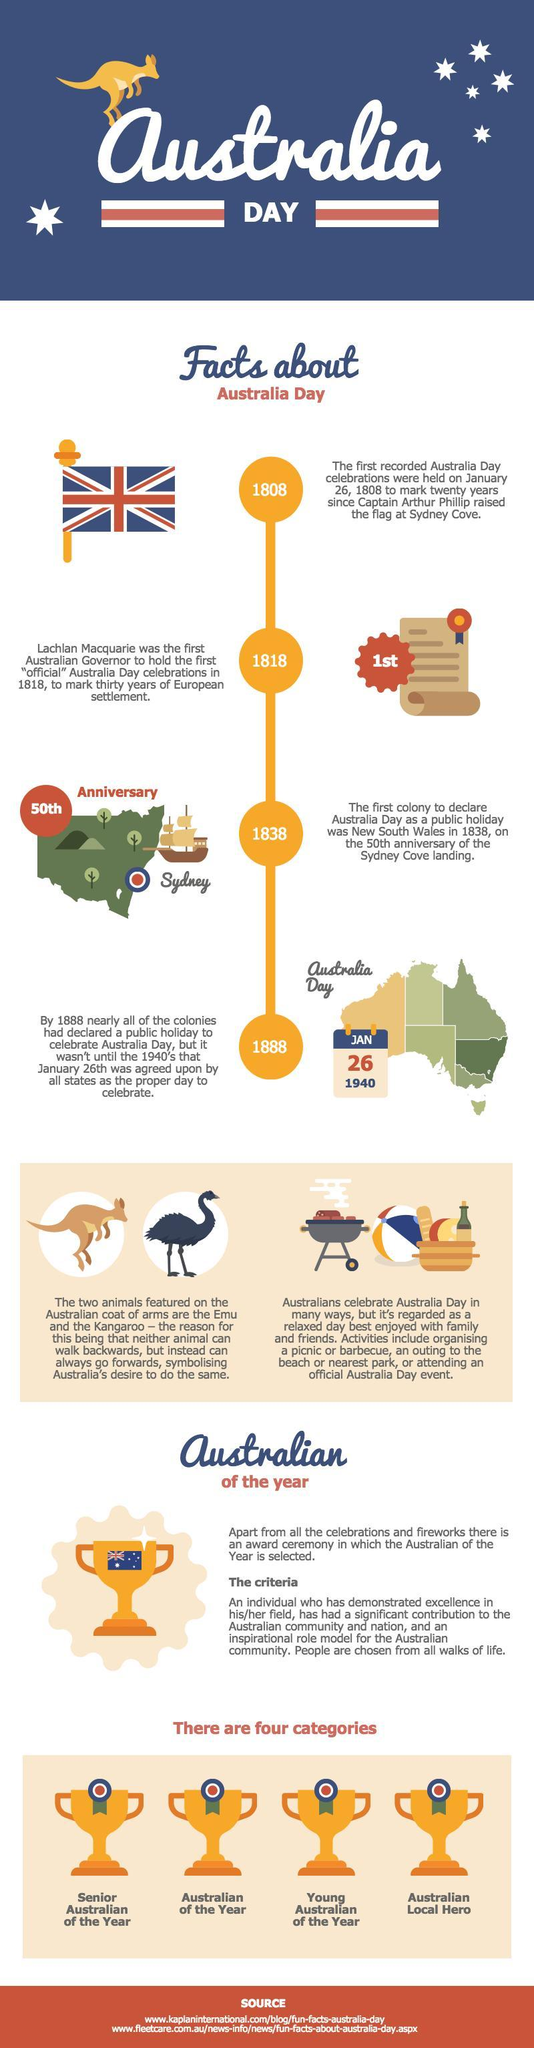When was the first recorded Australia Day celebrations held?
Answer the question with a short phrase. January 26, 1808 Which was the first colony to declare Australia Day as a public holiday? New South Wales 